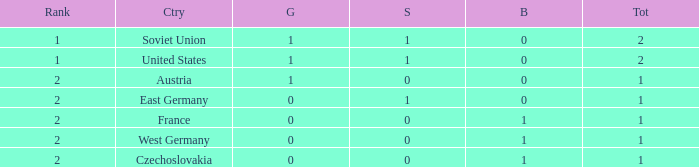What is the top position of austria, having fewer than 0 silvers? None. 